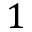Convert formula to latex. <formula><loc_0><loc_0><loc_500><loc_500>1</formula> 